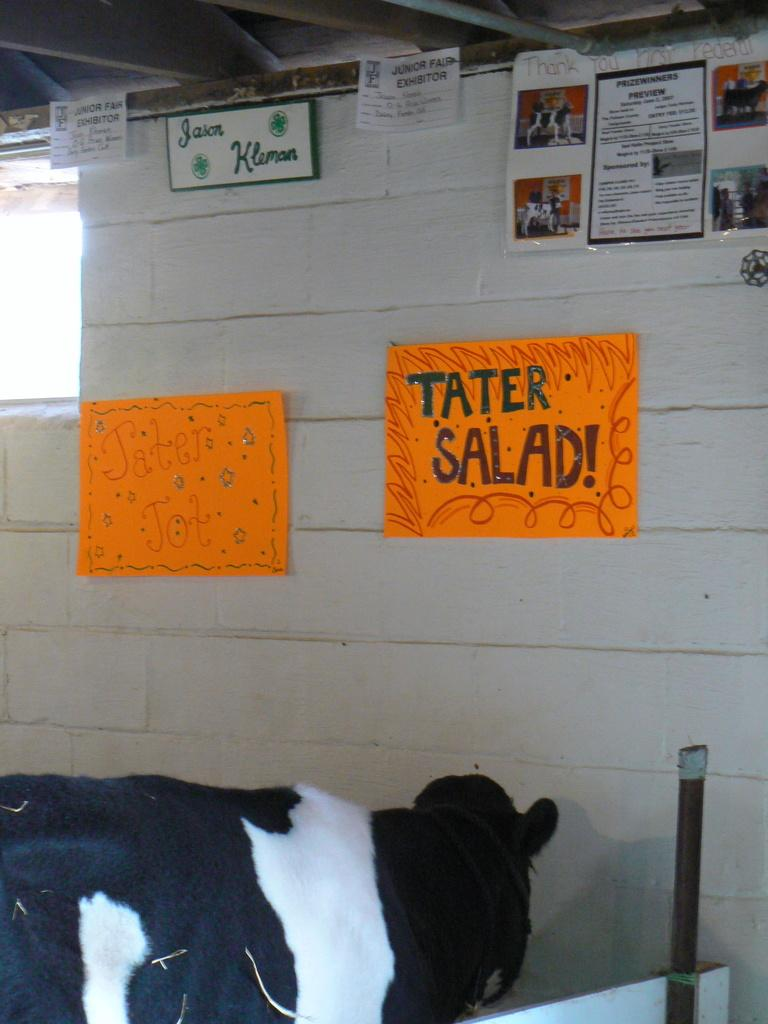What animal is present in the image? There is a cow in the image. What can be seen on the wall in the image? There are posts on a wall in the image. Is there any opening to the outside in the image? Yes, there is a window in the image. What type of riddle can be seen written on the cow in the image? There is no riddle written on the cow in the image; it is a cow standing in a setting with posts on a wall and a window. 